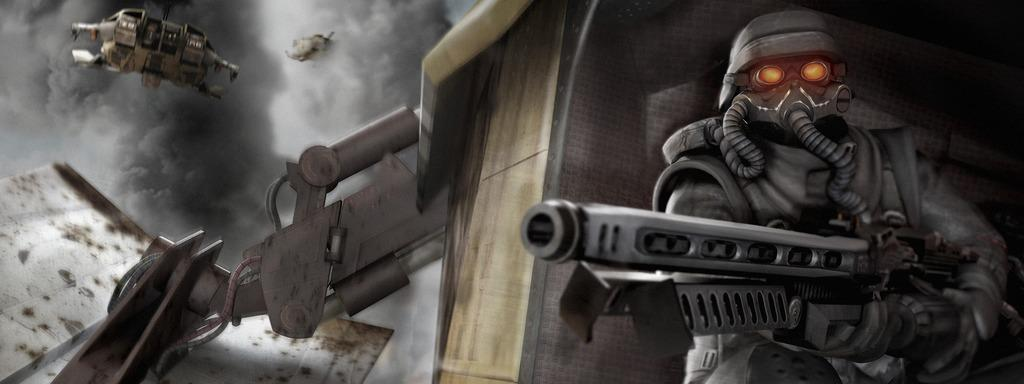What is the person in the image holding? The person in the image is holding a gun. Can you describe the object in the image? Unfortunately, the provided facts do not give any information about the object in the image. What can be seen in the air in the image? There is an airplane in the air in the image. What is visible in the sky in the image? The sky is visible in the image, and there are clouds present. How does the person in the image use the whip? There is no whip present in the image; the person is holding a gun. Can you describe the trade that is taking place in the image? There is no trade taking place in the image; the focus is on the person holding a gun and the airplane in the sky. 